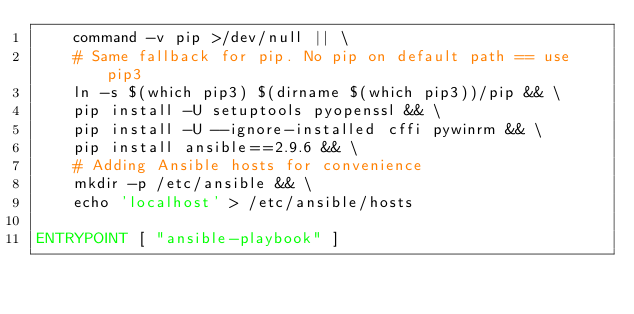Convert code to text. <code><loc_0><loc_0><loc_500><loc_500><_Dockerfile_>    command -v pip >/dev/null || \
    # Same fallback for pip. No pip on default path == use pip3
    ln -s $(which pip3) $(dirname $(which pip3))/pip && \
    pip install -U setuptools pyopenssl && \
    pip install -U --ignore-installed cffi pywinrm && \
    pip install ansible==2.9.6 && \
    # Adding Ansible hosts for convenience
    mkdir -p /etc/ansible && \
    echo 'localhost' > /etc/ansible/hosts

ENTRYPOINT [ "ansible-playbook" ]</code> 